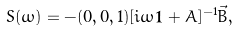<formula> <loc_0><loc_0><loc_500><loc_500>S ( \omega ) = - ( 0 , 0 , 1 ) [ i \omega { \mathbf 1 } + A ] ^ { - 1 } \vec { B } ,</formula> 